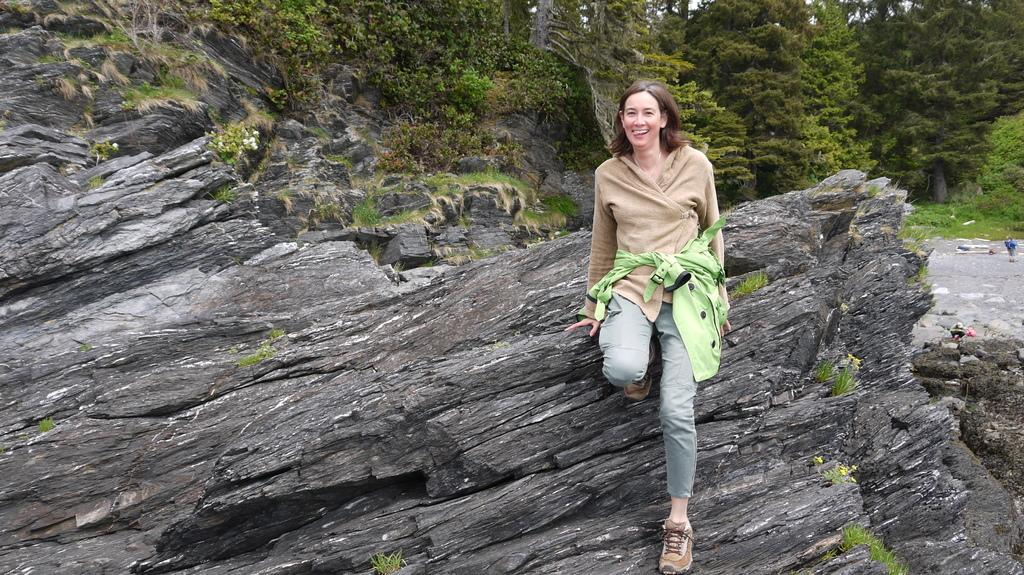Who or what can be seen in the image? There are people in the image. What type of natural elements are present in the image? There are trees, rocks, and a mountain in the image. What is visible in the background of the image? The sky is visible in the image. What type of zinc object can be seen in the image? There is no zinc object present in the image. Can you see a basket being used by the people in the image? There is no basket visible in the image. 